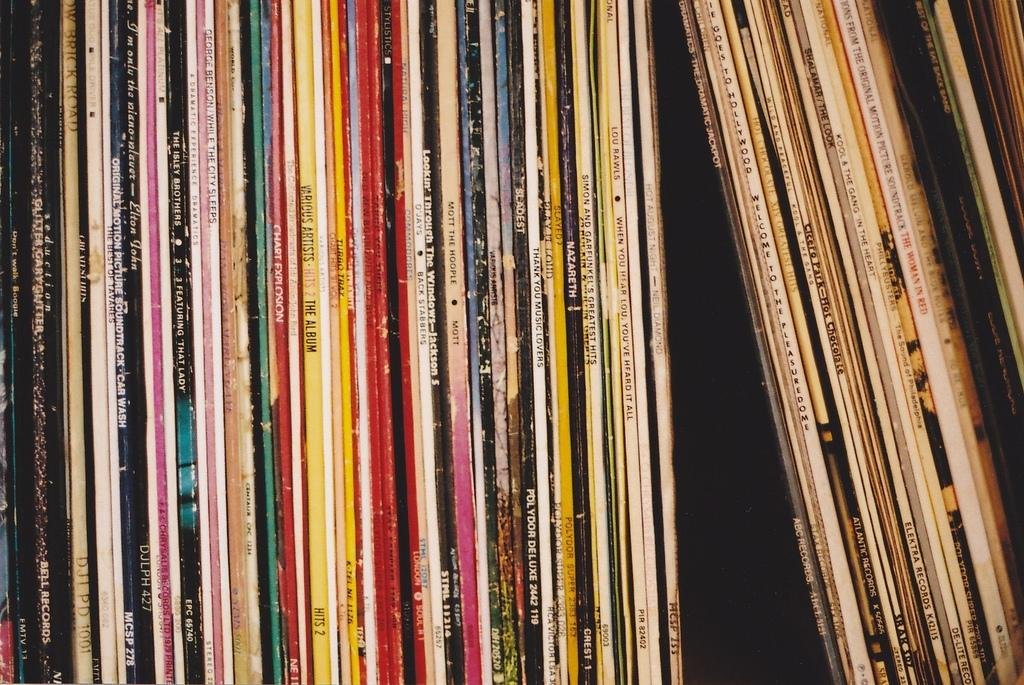<image>
Give a short and clear explanation of the subsequent image. A bunch of stacked records and one of the records is by Lou Rawls. 